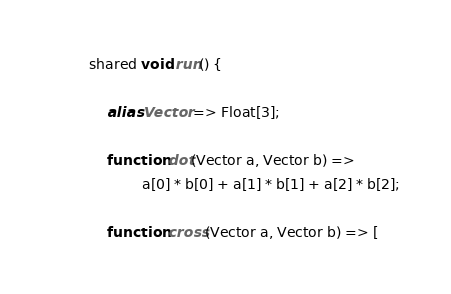Convert code to text. <code><loc_0><loc_0><loc_500><loc_500><_Ceylon_>shared void run() {

	alias Vector => Float[3];
	
	function dot(Vector a, Vector b) =>
			a[0] * b[0] + a[1] * b[1] + a[2] * b[2];
	
	function cross(Vector a, Vector b) => [</code> 